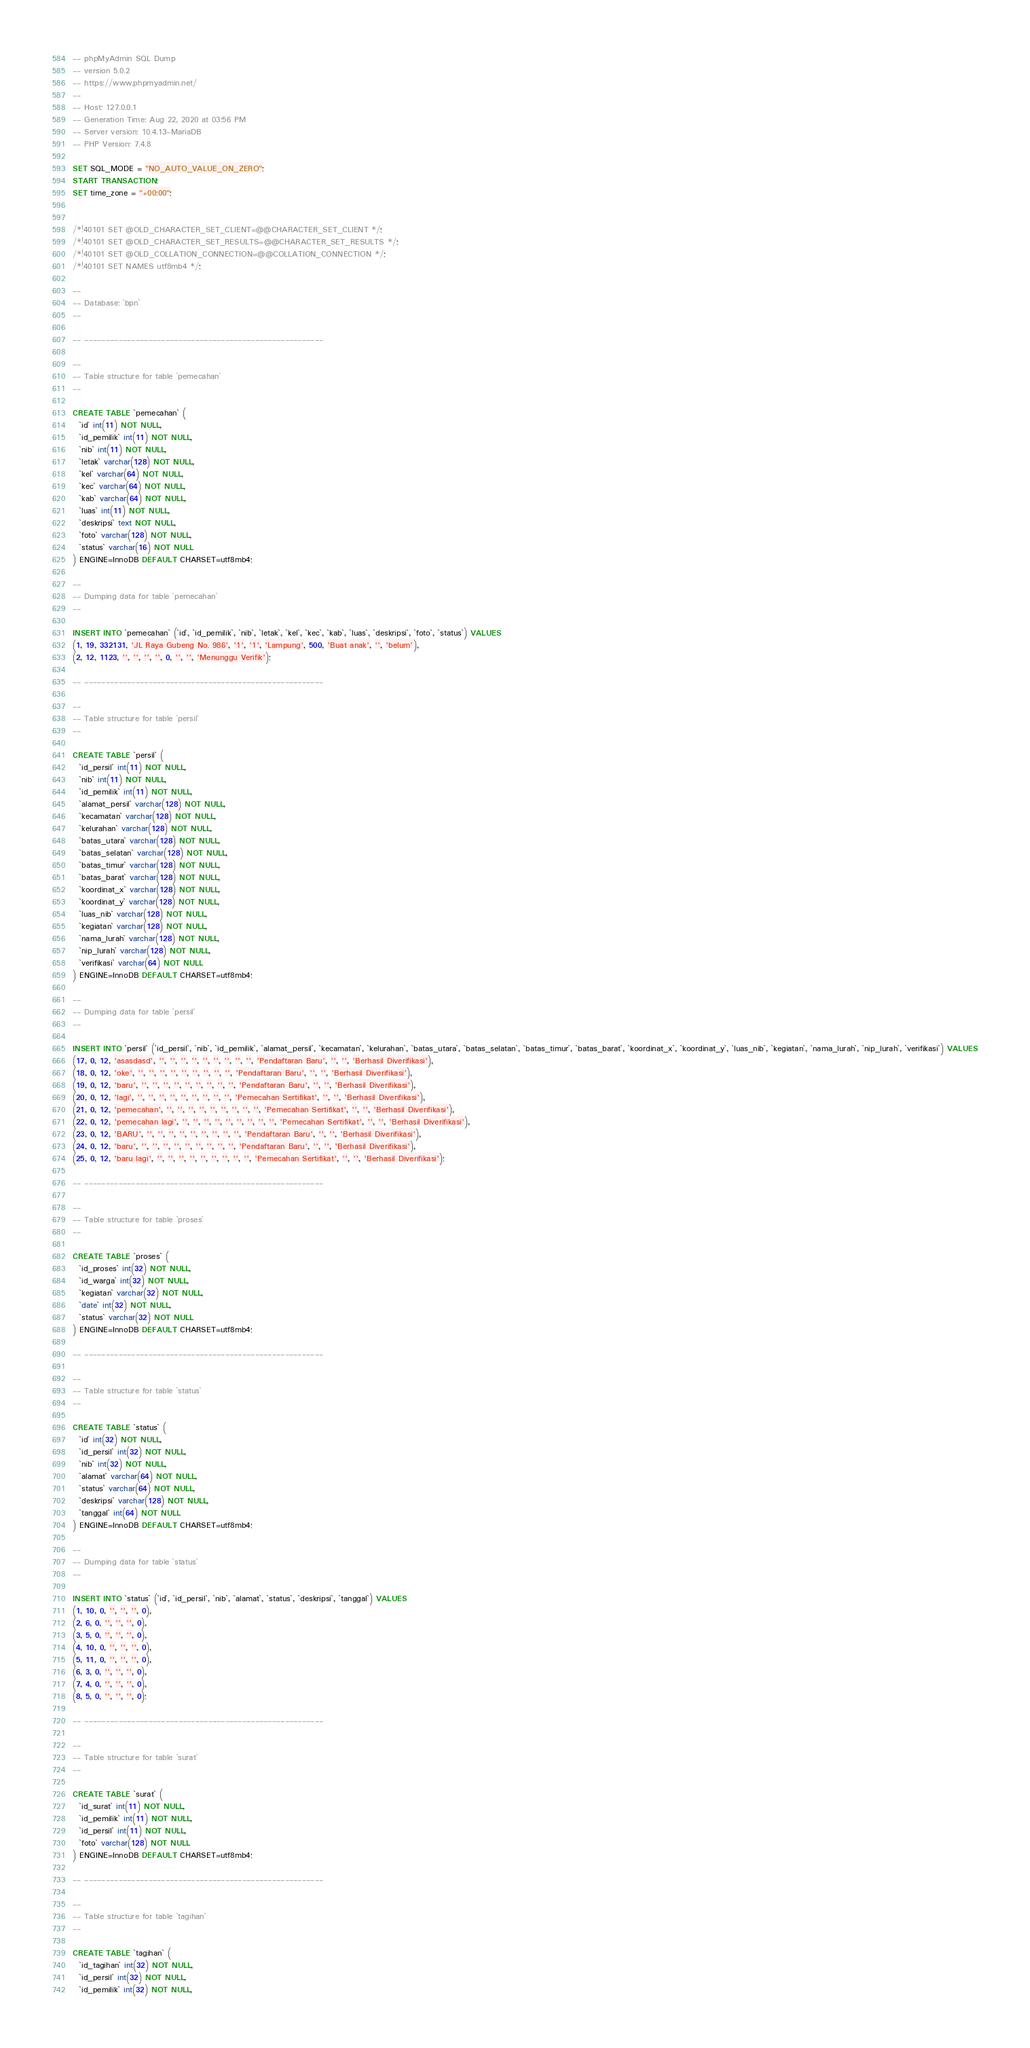<code> <loc_0><loc_0><loc_500><loc_500><_SQL_>-- phpMyAdmin SQL Dump
-- version 5.0.2
-- https://www.phpmyadmin.net/
--
-- Host: 127.0.0.1
-- Generation Time: Aug 22, 2020 at 03:56 PM
-- Server version: 10.4.13-MariaDB
-- PHP Version: 7.4.8

SET SQL_MODE = "NO_AUTO_VALUE_ON_ZERO";
START TRANSACTION;
SET time_zone = "+00:00";


/*!40101 SET @OLD_CHARACTER_SET_CLIENT=@@CHARACTER_SET_CLIENT */;
/*!40101 SET @OLD_CHARACTER_SET_RESULTS=@@CHARACTER_SET_RESULTS */;
/*!40101 SET @OLD_COLLATION_CONNECTION=@@COLLATION_CONNECTION */;
/*!40101 SET NAMES utf8mb4 */;

--
-- Database: `bpn`
--

-- --------------------------------------------------------

--
-- Table structure for table `pemecahan`
--

CREATE TABLE `pemecahan` (
  `id` int(11) NOT NULL,
  `id_pemilik` int(11) NOT NULL,
  `nib` int(11) NOT NULL,
  `letak` varchar(128) NOT NULL,
  `kel` varchar(64) NOT NULL,
  `kec` varchar(64) NOT NULL,
  `kab` varchar(64) NOT NULL,
  `luas` int(11) NOT NULL,
  `deskripsi` text NOT NULL,
  `foto` varchar(128) NOT NULL,
  `status` varchar(16) NOT NULL
) ENGINE=InnoDB DEFAULT CHARSET=utf8mb4;

--
-- Dumping data for table `pemecahan`
--

INSERT INTO `pemecahan` (`id`, `id_pemilik`, `nib`, `letak`, `kel`, `kec`, `kab`, `luas`, `deskripsi`, `foto`, `status`) VALUES
(1, 19, 332131, 'JL Raya Gubeng No. 986', '1', '1', 'Lampung', 500, 'Buat anak', '', 'belum'),
(2, 12, 1123, '', '', '', '', 0, '', '', 'Menunggu Verifik');

-- --------------------------------------------------------

--
-- Table structure for table `persil`
--

CREATE TABLE `persil` (
  `id_persil` int(11) NOT NULL,
  `nib` int(11) NOT NULL,
  `id_pemilik` int(11) NOT NULL,
  `alamat_persil` varchar(128) NOT NULL,
  `kecamatan` varchar(128) NOT NULL,
  `kelurahan` varchar(128) NOT NULL,
  `batas_utara` varchar(128) NOT NULL,
  `batas_selatan` varchar(128) NOT NULL,
  `batas_timur` varchar(128) NOT NULL,
  `batas_barat` varchar(128) NOT NULL,
  `koordinat_x` varchar(128) NOT NULL,
  `koordinat_y` varchar(128) NOT NULL,
  `luas_nib` varchar(128) NOT NULL,
  `kegiatan` varchar(128) NOT NULL,
  `nama_lurah` varchar(128) NOT NULL,
  `nip_lurah` varchar(128) NOT NULL,
  `verifikasi` varchar(64) NOT NULL
) ENGINE=InnoDB DEFAULT CHARSET=utf8mb4;

--
-- Dumping data for table `persil`
--

INSERT INTO `persil` (`id_persil`, `nib`, `id_pemilik`, `alamat_persil`, `kecamatan`, `kelurahan`, `batas_utara`, `batas_selatan`, `batas_timur`, `batas_barat`, `koordinat_x`, `koordinat_y`, `luas_nib`, `kegiatan`, `nama_lurah`, `nip_lurah`, `verifikasi`) VALUES
(17, 0, 12, 'asasdasd', '', '', '', '', '', '', '', '', '', 'Pendaftaran Baru', '', '', 'Berhasil Diverifikasi'),
(18, 0, 12, 'oke', '', '', '', '', '', '', '', '', '', 'Pendaftaran Baru', '', '', 'Berhasil Diverifikasi'),
(19, 0, 12, 'baru', '', '', '', '', '', '', '', '', '', 'Pendaftaran Baru', '', '', 'Berhasil Diverifikasi'),
(20, 0, 12, 'lagi', '', '', '', '', '', '', '', '', '', 'Pemecahan Sertifikat', '', '', 'Berhasil Diverifikasi'),
(21, 0, 12, 'pemecahan', '', '', '', '', '', '', '', '', '', 'Pemecahan Sertifikat', '', '', 'Berhasil Diverifikasi'),
(22, 0, 12, 'pemecahan lagi', '', '', '', '', '', '', '', '', '', 'Pemecahan Sertifikat', '', '', 'Berhasil Diverifikasi'),
(23, 0, 12, 'BARU', '', '', '', '', '', '', '', '', '', 'Pendaftaran Baru', '', '', 'Berhasil Diverifikasi'),
(24, 0, 12, 'baru', '', '', '', '', '', '', '', '', '', 'Pendaftaran Baru', '', '', 'Berhasil Diverifikasi'),
(25, 0, 12, 'baru lagi', '', '', '', '', '', '', '', '', '', 'Pemecahan Sertifikat', '', '', 'Berhasil Diverifikasi');

-- --------------------------------------------------------

--
-- Table structure for table `proses`
--

CREATE TABLE `proses` (
  `id_proses` int(32) NOT NULL,
  `id_warga` int(32) NOT NULL,
  `kegiatan` varchar(32) NOT NULL,
  `date` int(32) NOT NULL,
  `status` varchar(32) NOT NULL
) ENGINE=InnoDB DEFAULT CHARSET=utf8mb4;

-- --------------------------------------------------------

--
-- Table structure for table `status`
--

CREATE TABLE `status` (
  `id` int(32) NOT NULL,
  `id_persil` int(32) NOT NULL,
  `nib` int(32) NOT NULL,
  `alamat` varchar(64) NOT NULL,
  `status` varchar(64) NOT NULL,
  `deskripsi` varchar(128) NOT NULL,
  `tanggal` int(64) NOT NULL
) ENGINE=InnoDB DEFAULT CHARSET=utf8mb4;

--
-- Dumping data for table `status`
--

INSERT INTO `status` (`id`, `id_persil`, `nib`, `alamat`, `status`, `deskripsi`, `tanggal`) VALUES
(1, 10, 0, '', '', '', 0),
(2, 6, 0, '', '', '', 0),
(3, 5, 0, '', '', '', 0),
(4, 10, 0, '', '', '', 0),
(5, 11, 0, '', '', '', 0),
(6, 3, 0, '', '', '', 0),
(7, 4, 0, '', '', '', 0),
(8, 5, 0, '', '', '', 0);

-- --------------------------------------------------------

--
-- Table structure for table `surat`
--

CREATE TABLE `surat` (
  `id_surat` int(11) NOT NULL,
  `id_pemilik` int(11) NOT NULL,
  `id_persil` int(11) NOT NULL,
  `foto` varchar(128) NOT NULL
) ENGINE=InnoDB DEFAULT CHARSET=utf8mb4;

-- --------------------------------------------------------

--
-- Table structure for table `tagihan`
--

CREATE TABLE `tagihan` (
  `id_tagihan` int(32) NOT NULL,
  `id_persil` int(32) NOT NULL,
  `id_pemilik` int(32) NOT NULL,</code> 